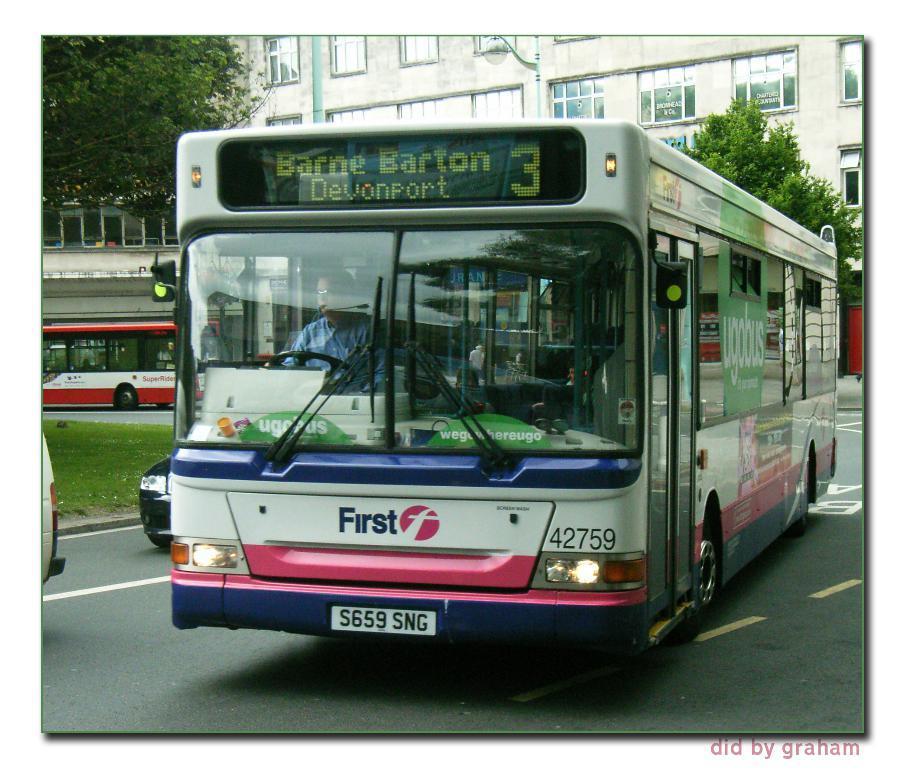Where was the image taken? The image was clicked outside. What can be seen at the top of the image? There is a building at the top of the image. What mode of transportation is visible in the middle of the image? There are buses in the middle of the image. What type of vegetation is present on the left side of the image? There is grass and trees on the left side of the image. Are there any trees visible on the right side of the image? Yes, there are trees on the right side of the image. What grade of wood is used to construct the beam in the image? There is no beam present in the image, so it is not possible to determine the grade of wood used. 